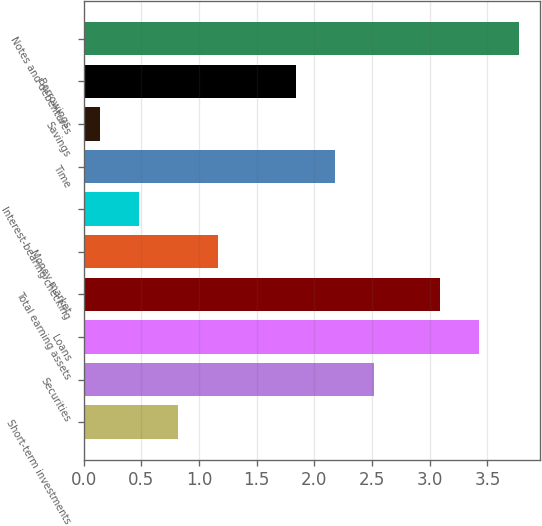<chart> <loc_0><loc_0><loc_500><loc_500><bar_chart><fcel>Short-term investments<fcel>Securities<fcel>Loans<fcel>Total earning assets<fcel>Money market<fcel>Interest-bearing checking<fcel>Time<fcel>Savings<fcel>Borrowings<fcel>Notes and debentures<nl><fcel>0.82<fcel>2.52<fcel>3.43<fcel>3.09<fcel>1.16<fcel>0.48<fcel>2.18<fcel>0.14<fcel>1.84<fcel>3.77<nl></chart> 